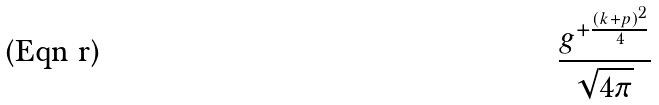Convert formula to latex. <formula><loc_0><loc_0><loc_500><loc_500>\frac { g ^ { + \frac { ( k + p ) ^ { 2 } } { 4 } } } { \sqrt { 4 \pi } }</formula> 